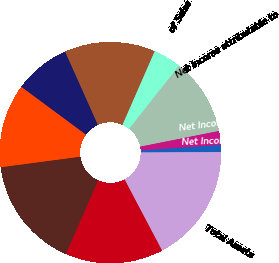Convert chart to OTSL. <chart><loc_0><loc_0><loc_500><loc_500><pie_chart><fcel>Net Sales<fcel>Marketing<fcel>Research & Development<fcel>Income from Operations (2346)<fcel>of Sales<fcel>Net Income attributable to<fcel>Net Income per Share-Basic (6)<fcel>Net Income per Share-Diluted<fcel>Total Assets<fcel>Total Debt (4)<nl><fcel>16.33%<fcel>12.24%<fcel>8.16%<fcel>13.27%<fcel>4.08%<fcel>11.22%<fcel>2.04%<fcel>1.02%<fcel>17.35%<fcel>14.29%<nl></chart> 